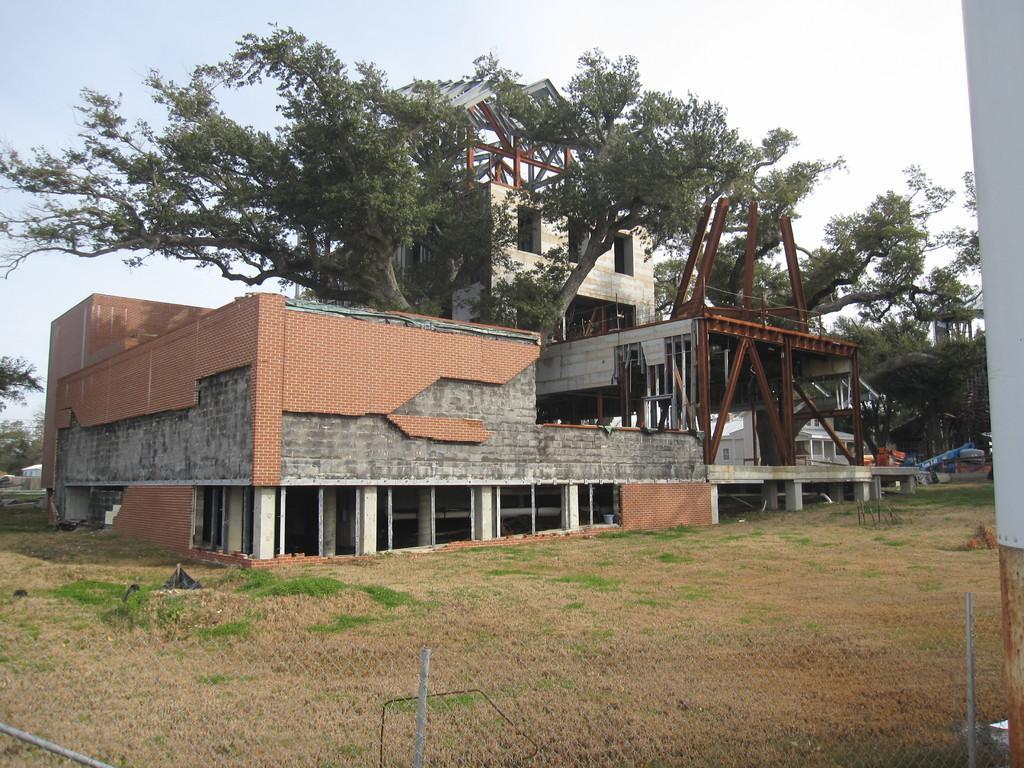In one or two sentences, can you explain what this image depicts? It is a building which is under construction and there are some trees in between the buildings,in front of the building there is a grass and there is a fencing around the building. 